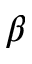Convert formula to latex. <formula><loc_0><loc_0><loc_500><loc_500>\beta</formula> 